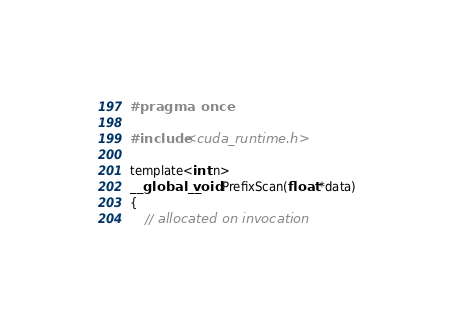<code> <loc_0><loc_0><loc_500><loc_500><_Cuda_>#pragma once

#include <cuda_runtime.h>

template<int n>
__global__ void PrefixScan(float *data)
{
	// allocated on invocation</code> 